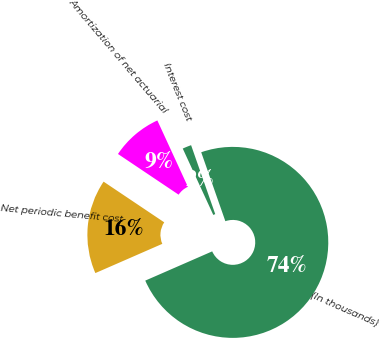Convert chart to OTSL. <chart><loc_0><loc_0><loc_500><loc_500><pie_chart><fcel>(In thousands)<fcel>Interest cost<fcel>Amortization of net actuarial<fcel>Net periodic benefit cost<nl><fcel>73.8%<fcel>1.5%<fcel>8.73%<fcel>15.96%<nl></chart> 